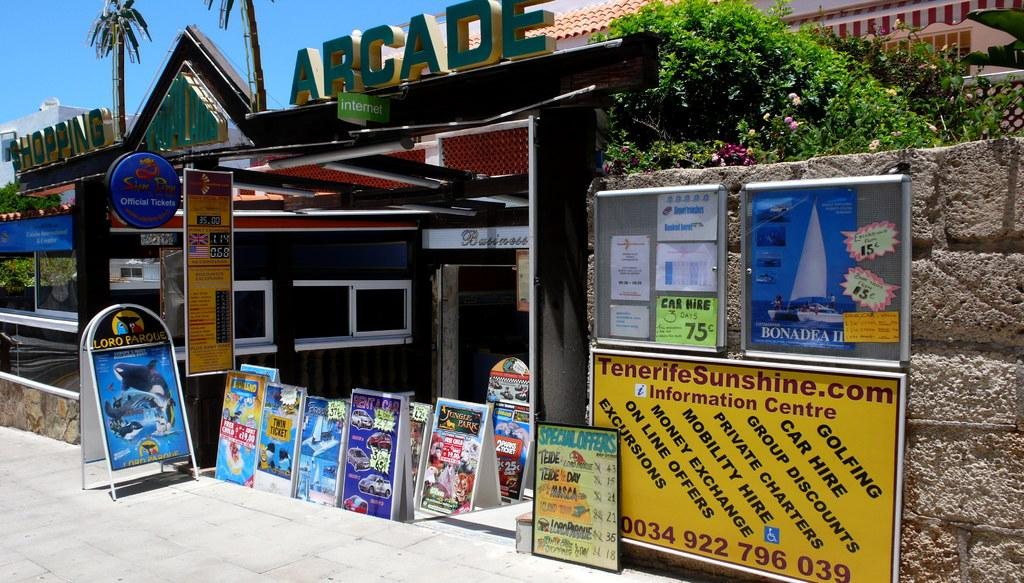What objects are present in the image that are made of wood? There are boards in the image that are made of wood. What type of structure can be seen in the image? There is a wall and a building visible in the image. What type of vegetation is present in the image? There are trees in the image. What part of the natural environment is visible in the image? The sky is visible in the image. What is written on the boards in the image? There is writing on the boards in the image. How many buildings can be seen in the image? There are two buildings visible in the image. What type of fairies can be seen flying around the trees in the image? There are no fairies present in the image; it only features boards, a wall, trees, buildings, and the sky. What type of breakfast is being served on the boards in the image? There is no breakfast present in the image; it only features boards with writing on them. 